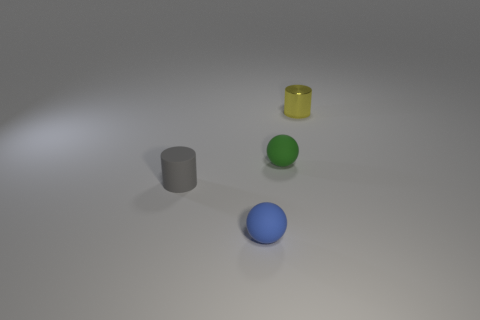Is the material of the blue thing the same as the yellow object?
Make the answer very short. No. What color is the small matte thing that is both behind the blue thing and in front of the green object?
Offer a very short reply. Gray. Is there a yellow cylinder of the same size as the gray cylinder?
Keep it short and to the point. Yes. There is a rubber sphere in front of the small matte ball behind the tiny rubber cylinder; what size is it?
Your answer should be very brief. Small. Are there fewer yellow shiny things that are right of the tiny gray object than small gray cylinders?
Provide a short and direct response. No. Does the tiny rubber cylinder have the same color as the small shiny cylinder?
Your answer should be very brief. No. The yellow cylinder is what size?
Give a very brief answer. Small. How many tiny rubber cylinders are the same color as the tiny metal cylinder?
Your answer should be very brief. 0. Is there a blue object right of the thing that is behind the rubber thing that is right of the blue sphere?
Provide a short and direct response. No. What is the shape of the blue matte object that is the same size as the gray matte thing?
Provide a short and direct response. Sphere. 